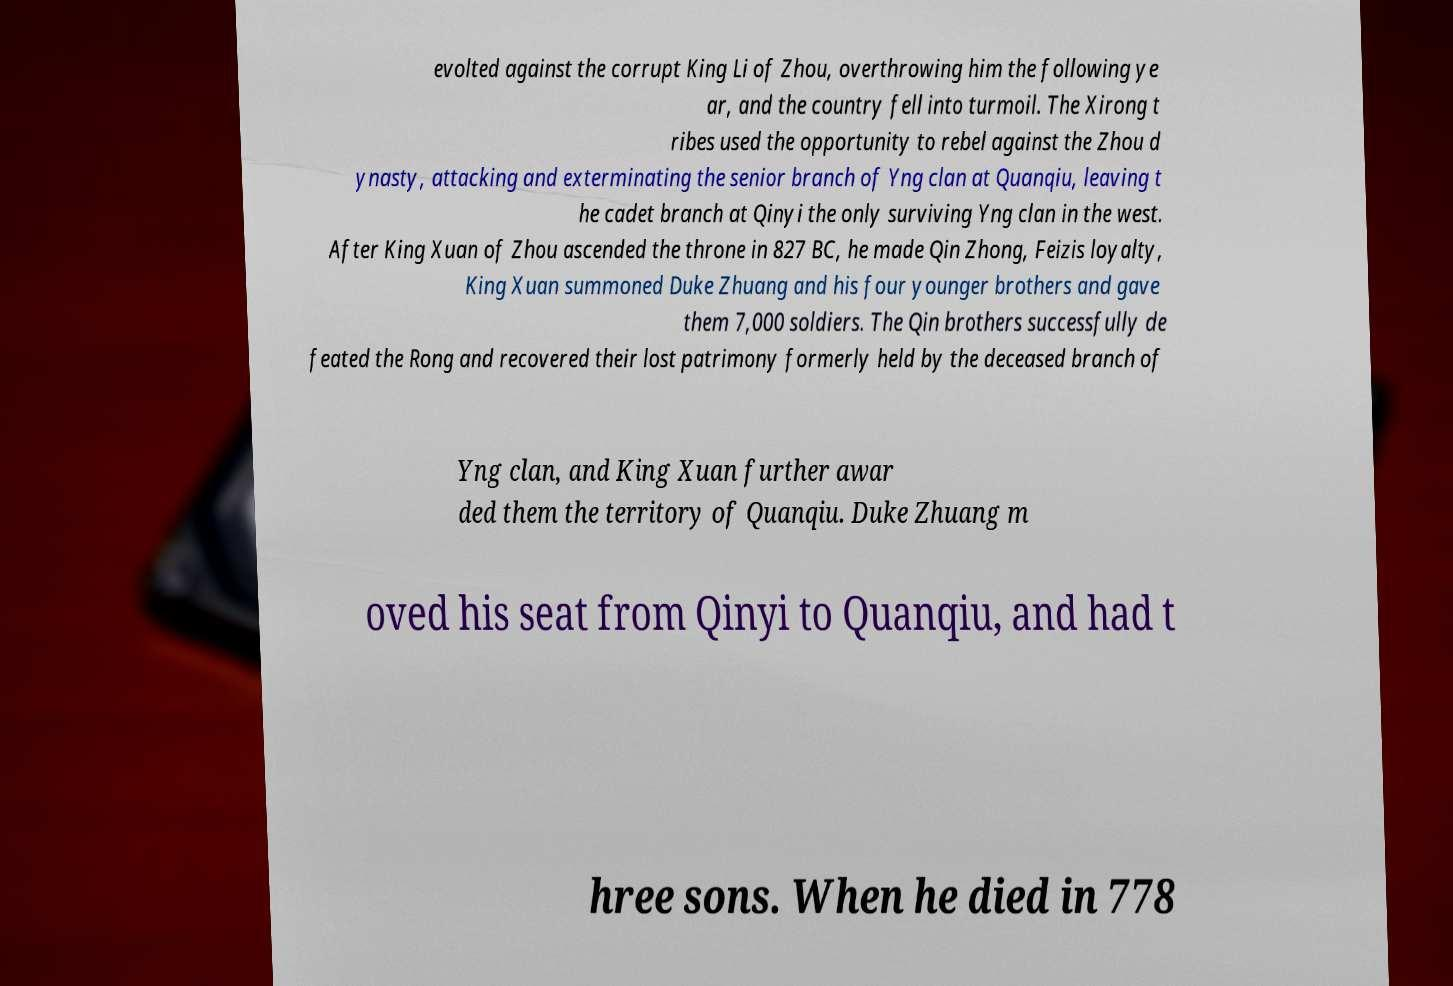What messages or text are displayed in this image? I need them in a readable, typed format. evolted against the corrupt King Li of Zhou, overthrowing him the following ye ar, and the country fell into turmoil. The Xirong t ribes used the opportunity to rebel against the Zhou d ynasty, attacking and exterminating the senior branch of Yng clan at Quanqiu, leaving t he cadet branch at Qinyi the only surviving Yng clan in the west. After King Xuan of Zhou ascended the throne in 827 BC, he made Qin Zhong, Feizis loyalty, King Xuan summoned Duke Zhuang and his four younger brothers and gave them 7,000 soldiers. The Qin brothers successfully de feated the Rong and recovered their lost patrimony formerly held by the deceased branch of Yng clan, and King Xuan further awar ded them the territory of Quanqiu. Duke Zhuang m oved his seat from Qinyi to Quanqiu, and had t hree sons. When he died in 778 